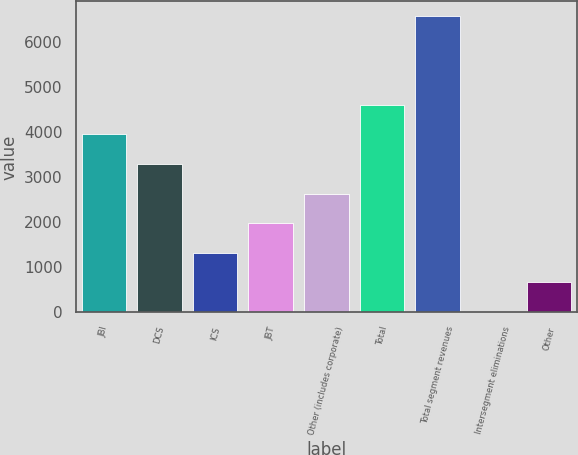Convert chart. <chart><loc_0><loc_0><loc_500><loc_500><bar_chart><fcel>JBI<fcel>DCS<fcel>ICS<fcel>JBT<fcel>Other (includes corporate)<fcel>Total<fcel>Total segment revenues<fcel>Intersegment eliminations<fcel>Other<nl><fcel>3947<fcel>3291.5<fcel>1325<fcel>1980.5<fcel>2636<fcel>4602.5<fcel>6569<fcel>14<fcel>669.5<nl></chart> 